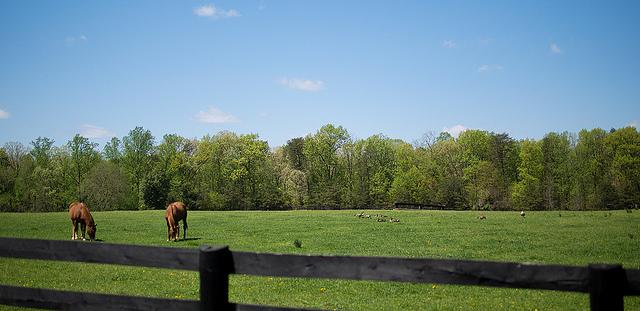What other type of large animal might be found in this environment? cow 